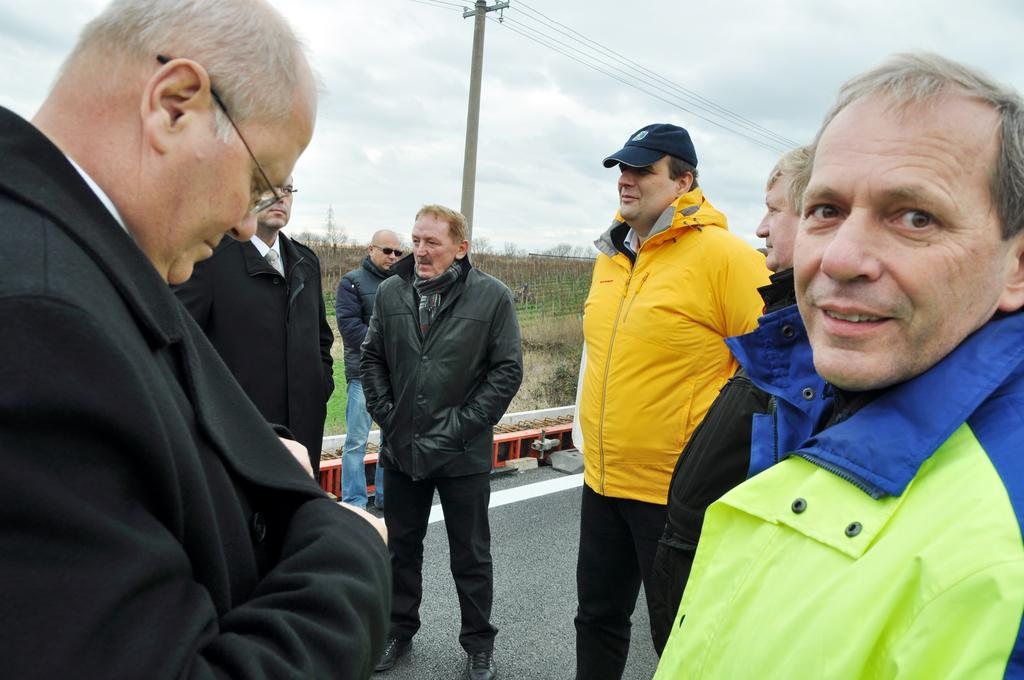What can be seen in the foreground of the image? There are men standing on the road. What is visible in the background of the image? There are trees, electric poles, wires, and clouds in the sky in the background of the image. What type of mint is being used by the men in the image? There is no mint present in the image; the men are standing on the road. Are the men holding umbrellas in the image? There is no mention of umbrellas in the image; the men are simply standing on the road. 